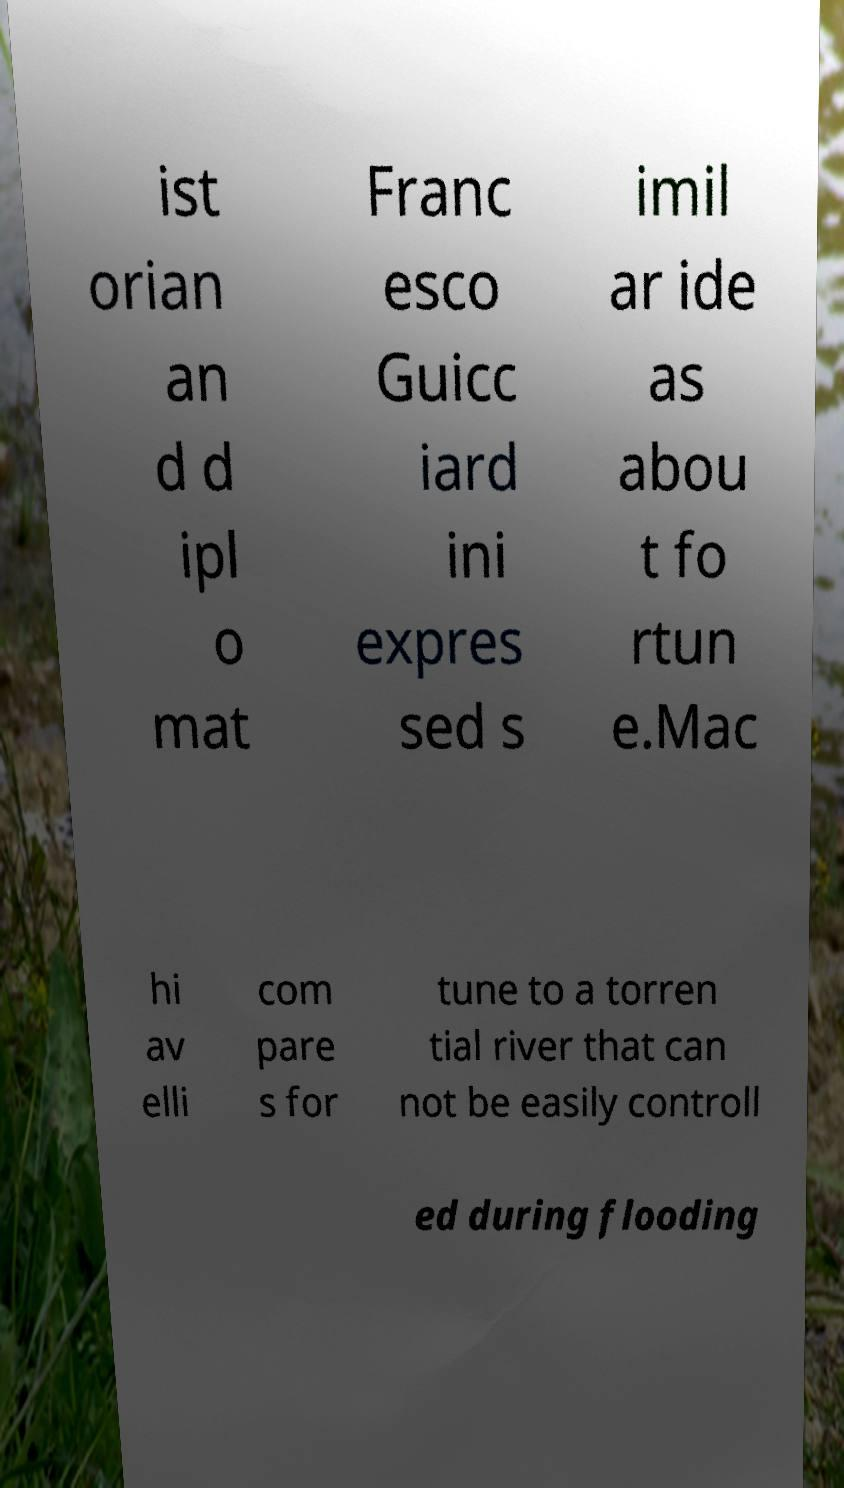Can you accurately transcribe the text from the provided image for me? ist orian an d d ipl o mat Franc esco Guicc iard ini expres sed s imil ar ide as abou t fo rtun e.Mac hi av elli com pare s for tune to a torren tial river that can not be easily controll ed during flooding 